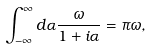<formula> <loc_0><loc_0><loc_500><loc_500>\int _ { - \infty } ^ { \infty } d \alpha \frac { \omega } { 1 + i \alpha } = \pi \omega ,</formula> 